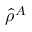<formula> <loc_0><loc_0><loc_500><loc_500>\hat { \rho } ^ { A }</formula> 